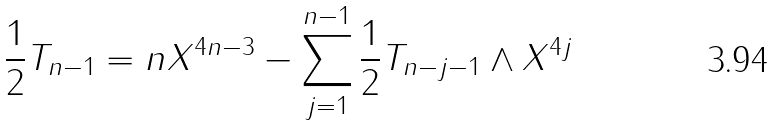Convert formula to latex. <formula><loc_0><loc_0><loc_500><loc_500>\frac { 1 } { 2 } T _ { n - 1 } = n X ^ { 4 n - 3 } - \sum _ { j = 1 } ^ { n - 1 } \frac { 1 } { 2 } T _ { n - j - 1 } \wedge X ^ { 4 j }</formula> 